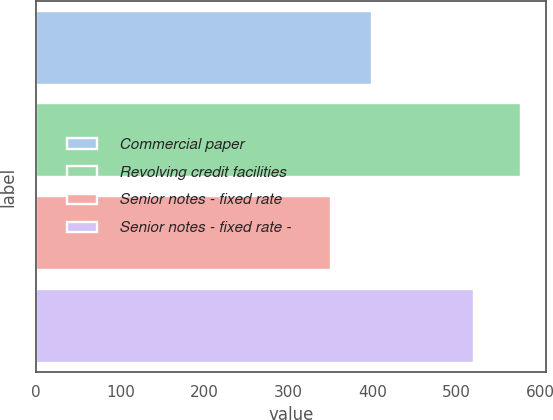<chart> <loc_0><loc_0><loc_500><loc_500><bar_chart><fcel>Commercial paper<fcel>Revolving credit facilities<fcel>Senior notes - fixed rate<fcel>Senior notes - fixed rate -<nl><fcel>398.7<fcel>576.8<fcel>350<fcel>520.7<nl></chart> 